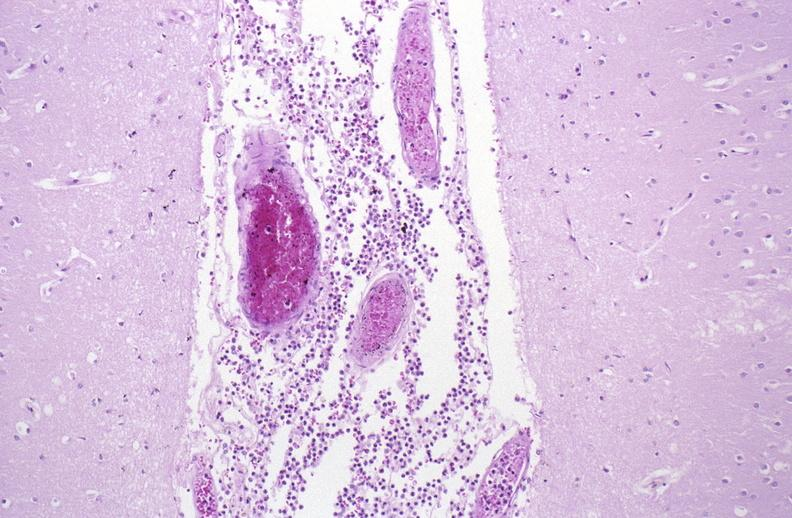s gout present?
Answer the question using a single word or phrase. No 